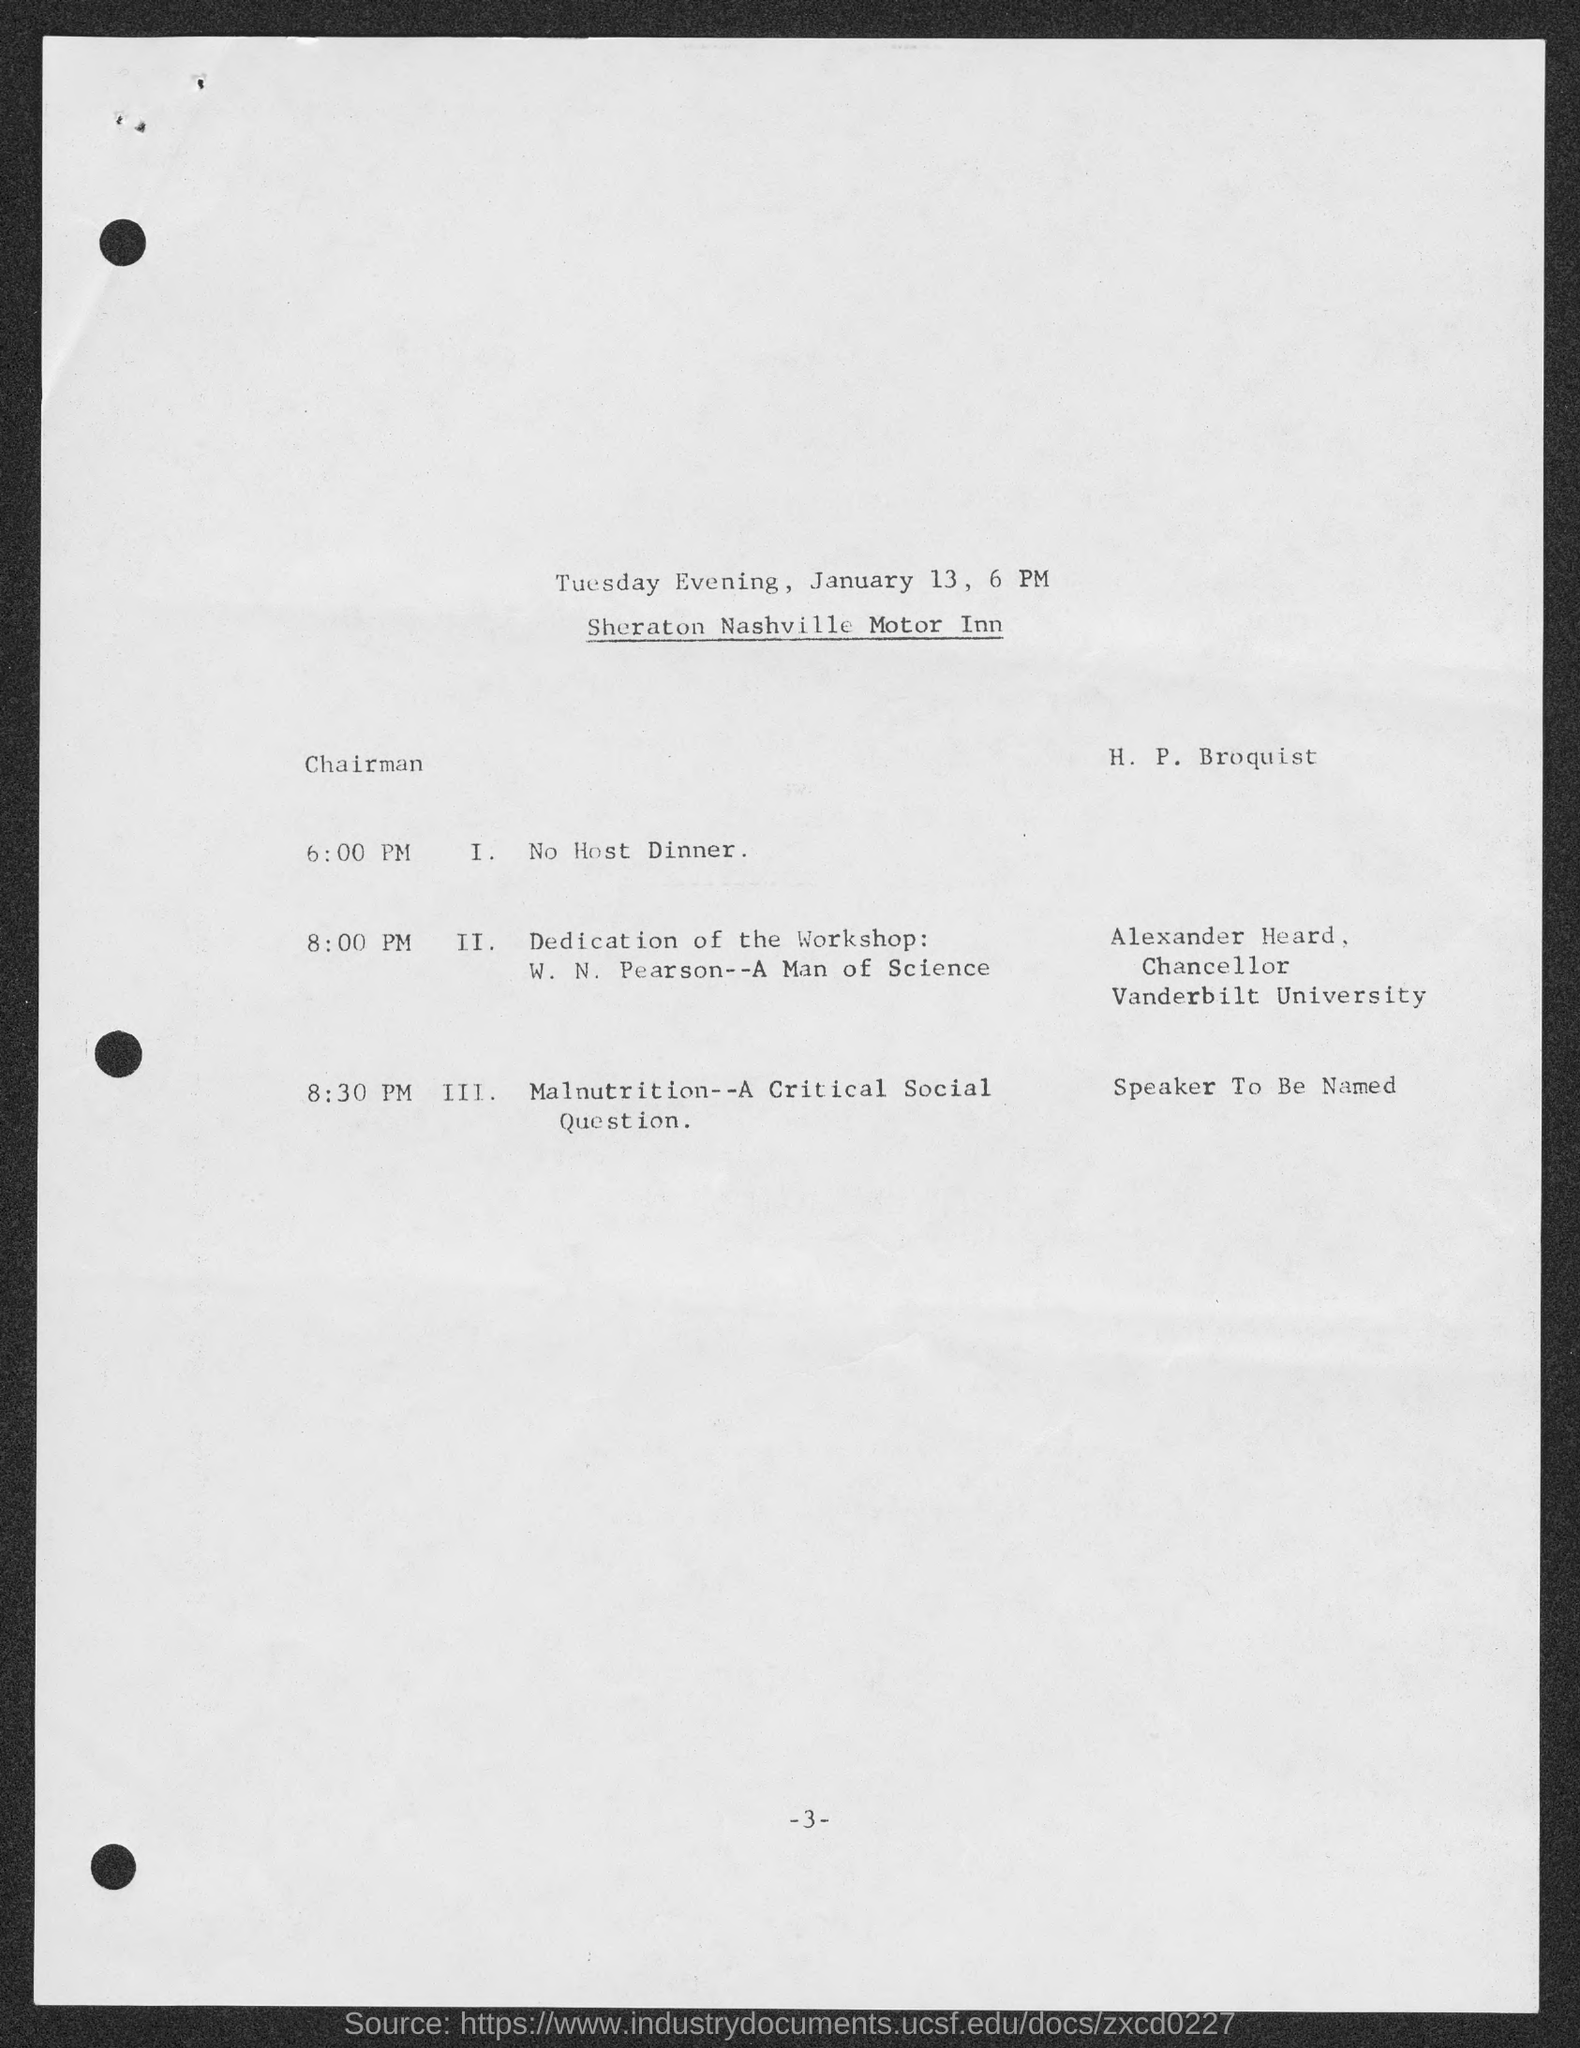What is the designation of alexander heard ?
Ensure brevity in your answer.  Chancellor. To which university alexander heard belongs to ?
Ensure brevity in your answer.  Vanderbilt university. What is the date mentioned in the given page ?
Make the answer very short. January 13. What is the schedule at the time of 8:00 pm ?
Provide a short and direct response. Dedication of the workshop. 